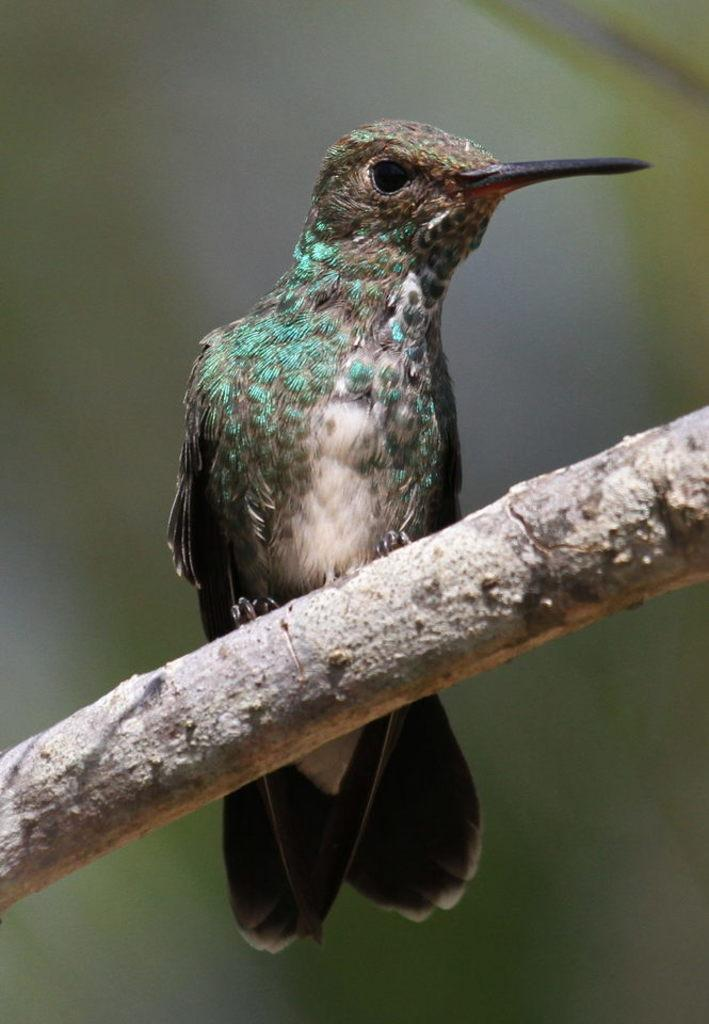What object can be seen in the image? There is a wooden stick in the image. What is on the wooden stick? A bird is present on the wooden stick. Can you describe the bird's appearance? The bird has white, brown, and blue colors. How would you describe the background of the image? The background of the image appears blurred. How much glue is needed to attach the bird to the wooden stick in the image? There is no glue present in the image, and the bird is naturally perched on the wooden stick. What is the size of the plate under the bird in the image? There is no plate present in the image; the bird is on a wooden stick. 